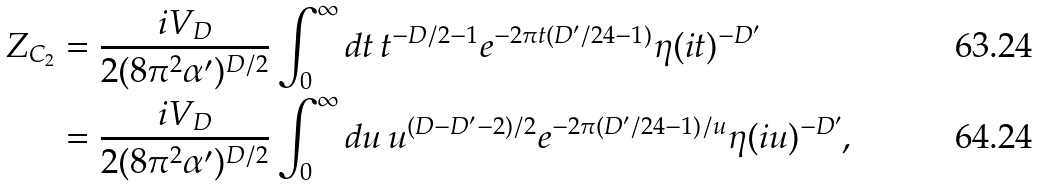Convert formula to latex. <formula><loc_0><loc_0><loc_500><loc_500>Z _ { C _ { 2 } } & = \frac { i V _ { D } } { 2 ( 8 \pi ^ { 2 } \alpha ^ { \prime } ) ^ { D / 2 } } \int _ { 0 } ^ { \infty } d t \, t ^ { - D / 2 - 1 } e ^ { - 2 \pi t ( D ^ { \prime } / 2 4 - 1 ) } \eta ( i t ) ^ { - D ^ { \prime } } \\ & = \frac { i V _ { D } } { 2 ( 8 \pi ^ { 2 } \alpha ^ { \prime } ) ^ { D / 2 } } \int _ { 0 } ^ { \infty } d u \, u ^ { ( D - D ^ { \prime } - 2 ) / 2 } e ^ { - 2 \pi ( D ^ { \prime } / 2 4 - 1 ) / u } \eta ( i u ) ^ { - D ^ { \prime } } ,</formula> 